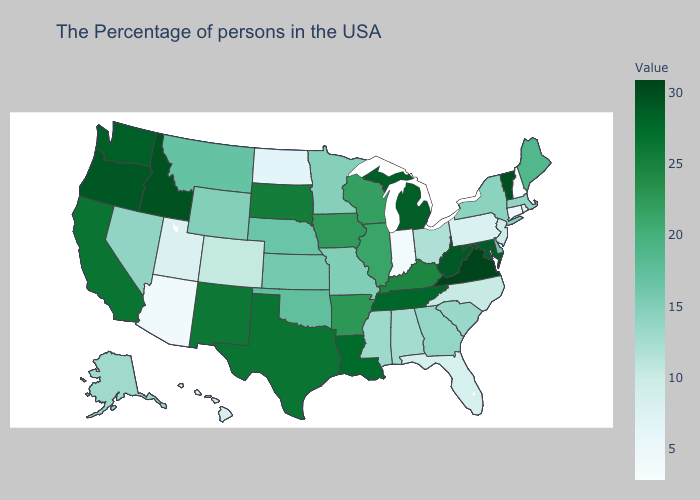Is the legend a continuous bar?
Give a very brief answer. Yes. Which states have the lowest value in the USA?
Concise answer only. New Hampshire. Does Kentucky have the highest value in the South?
Keep it brief. No. Among the states that border Louisiana , does Mississippi have the lowest value?
Keep it brief. Yes. Does Kentucky have the highest value in the USA?
Concise answer only. No. 